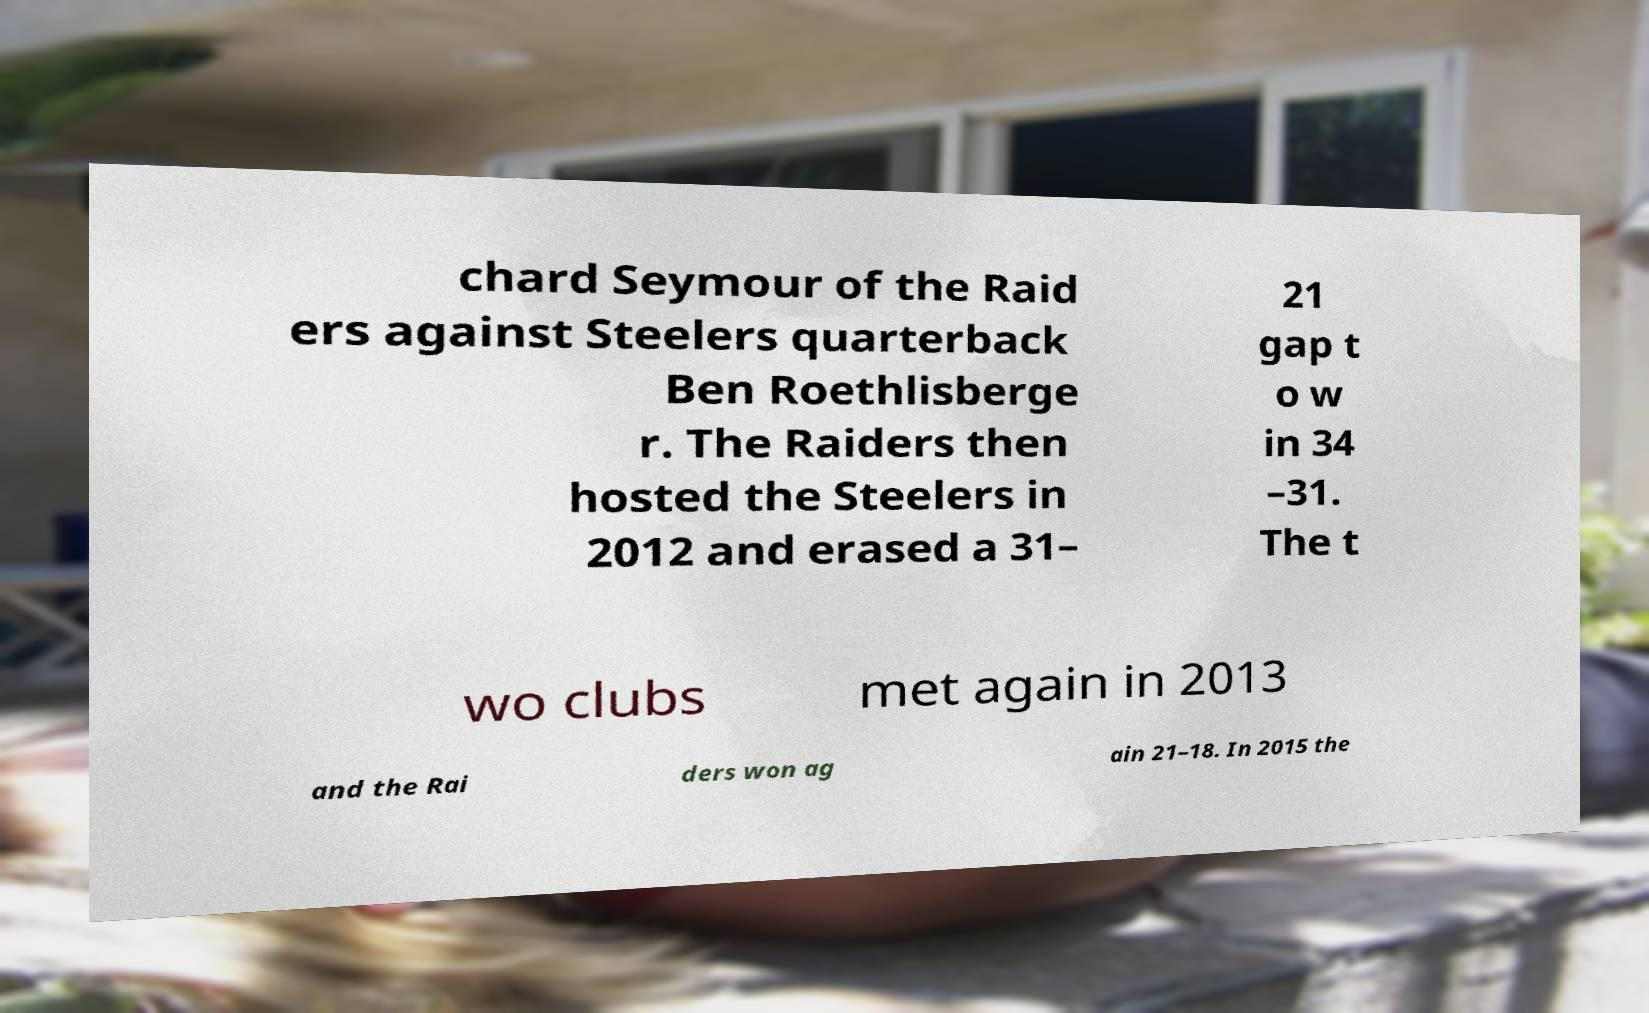What messages or text are displayed in this image? I need them in a readable, typed format. chard Seymour of the Raid ers against Steelers quarterback Ben Roethlisberge r. The Raiders then hosted the Steelers in 2012 and erased a 31– 21 gap t o w in 34 –31. The t wo clubs met again in 2013 and the Rai ders won ag ain 21–18. In 2015 the 